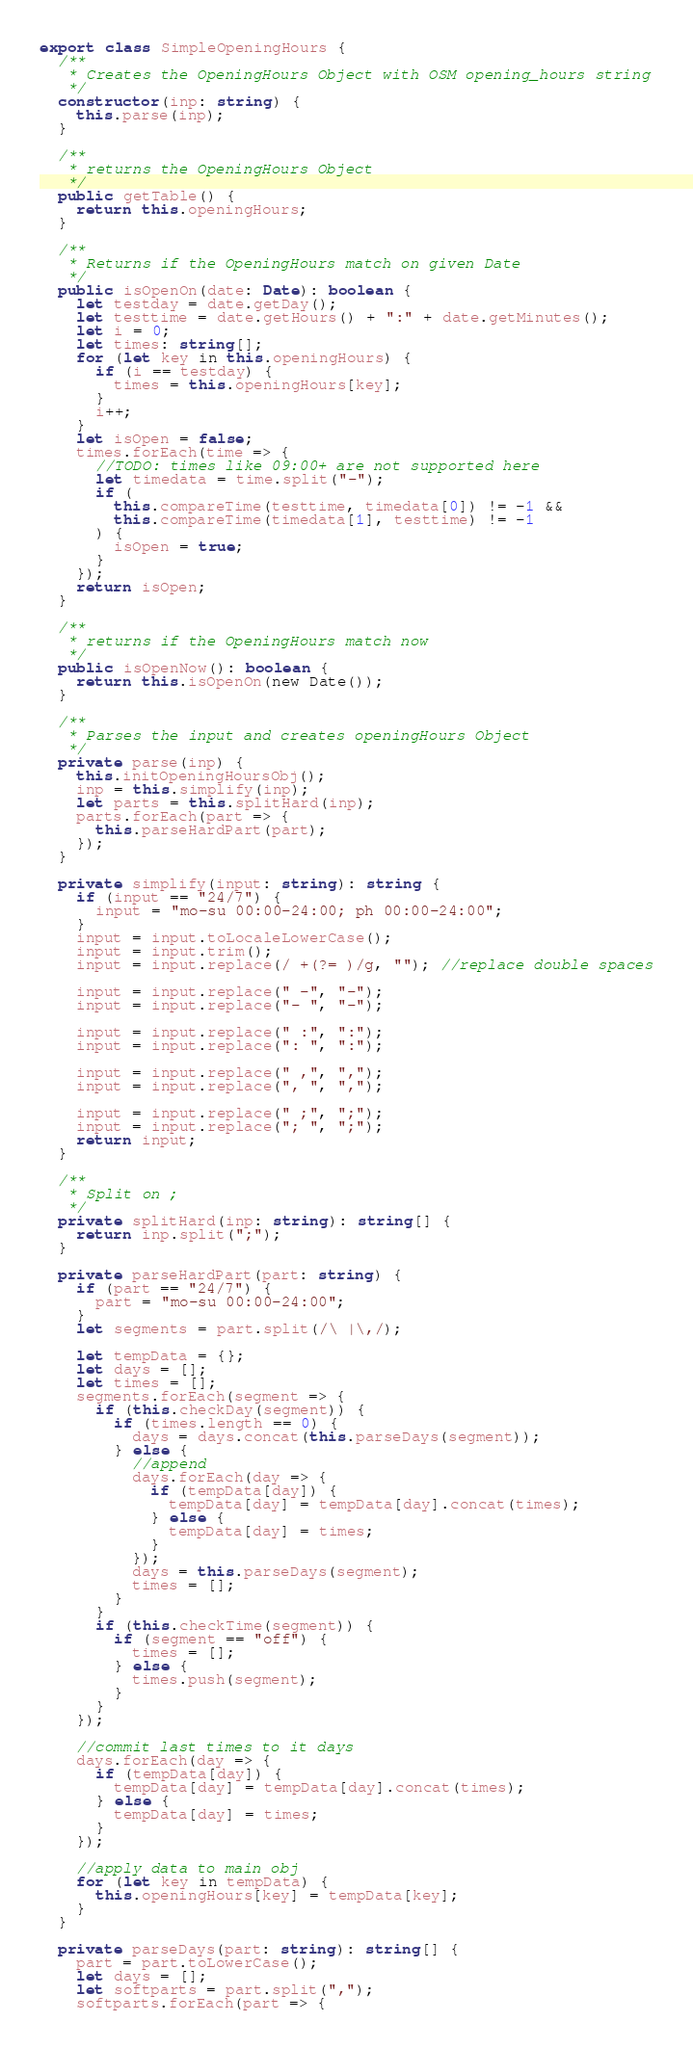<code> <loc_0><loc_0><loc_500><loc_500><_TypeScript_>export class SimpleOpeningHours {
  /**
   * Creates the OpeningHours Object with OSM opening_hours string
   */
  constructor(inp: string) {
    this.parse(inp);
  }

  /**
   * returns the OpeningHours Object
   */
  public getTable() {
    return this.openingHours;
  }

  /**
   * Returns if the OpeningHours match on given Date
   */
  public isOpenOn(date: Date): boolean {
    let testday = date.getDay();
    let testtime = date.getHours() + ":" + date.getMinutes();
    let i = 0;
    let times: string[];
    for (let key in this.openingHours) {
      if (i == testday) {
        times = this.openingHours[key];
      }
      i++;
    }
    let isOpen = false;
    times.forEach(time => {
      //TODO: times like 09:00+ are not supported here
      let timedata = time.split("-");
      if (
        this.compareTime(testtime, timedata[0]) != -1 &&
        this.compareTime(timedata[1], testtime) != -1
      ) {
        isOpen = true;
      }
    });
    return isOpen;
  }

  /**
   * returns if the OpeningHours match now
   */
  public isOpenNow(): boolean {
    return this.isOpenOn(new Date());
  }

  /**
   * Parses the input and creates openingHours Object
   */
  private parse(inp) {
    this.initOpeningHoursObj();
    inp = this.simplify(inp);
    let parts = this.splitHard(inp);
    parts.forEach(part => {
      this.parseHardPart(part);
    });
  }

  private simplify(input: string): string {
    if (input == "24/7") {
      input = "mo-su 00:00-24:00; ph 00:00-24:00";
    }
    input = input.toLocaleLowerCase();
    input = input.trim();
    input = input.replace(/ +(?= )/g, ""); //replace double spaces

    input = input.replace(" -", "-");
    input = input.replace("- ", "-");

    input = input.replace(" :", ":");
    input = input.replace(": ", ":");

    input = input.replace(" ,", ",");
    input = input.replace(", ", ",");

    input = input.replace(" ;", ";");
    input = input.replace("; ", ";");
    return input;
  }

  /**
   * Split on ;
   */
  private splitHard(inp: string): string[] {
    return inp.split(";");
  }

  private parseHardPart(part: string) {
    if (part == "24/7") {
      part = "mo-su 00:00-24:00";
    }
    let segments = part.split(/\ |\,/);

    let tempData = {};
    let days = [];
    let times = [];
    segments.forEach(segment => {
      if (this.checkDay(segment)) {
        if (times.length == 0) {
          days = days.concat(this.parseDays(segment));
        } else {
          //append
          days.forEach(day => {
            if (tempData[day]) {
              tempData[day] = tempData[day].concat(times);
            } else {
              tempData[day] = times;
            }
          });
          days = this.parseDays(segment);
          times = [];
        }
      }
      if (this.checkTime(segment)) {
        if (segment == "off") {
          times = [];
        } else {
          times.push(segment);
        }
      }
    });

    //commit last times to it days
    days.forEach(day => {
      if (tempData[day]) {
        tempData[day] = tempData[day].concat(times);
      } else {
        tempData[day] = times;
      }
    });

    //apply data to main obj
    for (let key in tempData) {
      this.openingHours[key] = tempData[key];
    }
  }

  private parseDays(part: string): string[] {
    part = part.toLowerCase();
    let days = [];
    let softparts = part.split(",");
    softparts.forEach(part => {</code> 